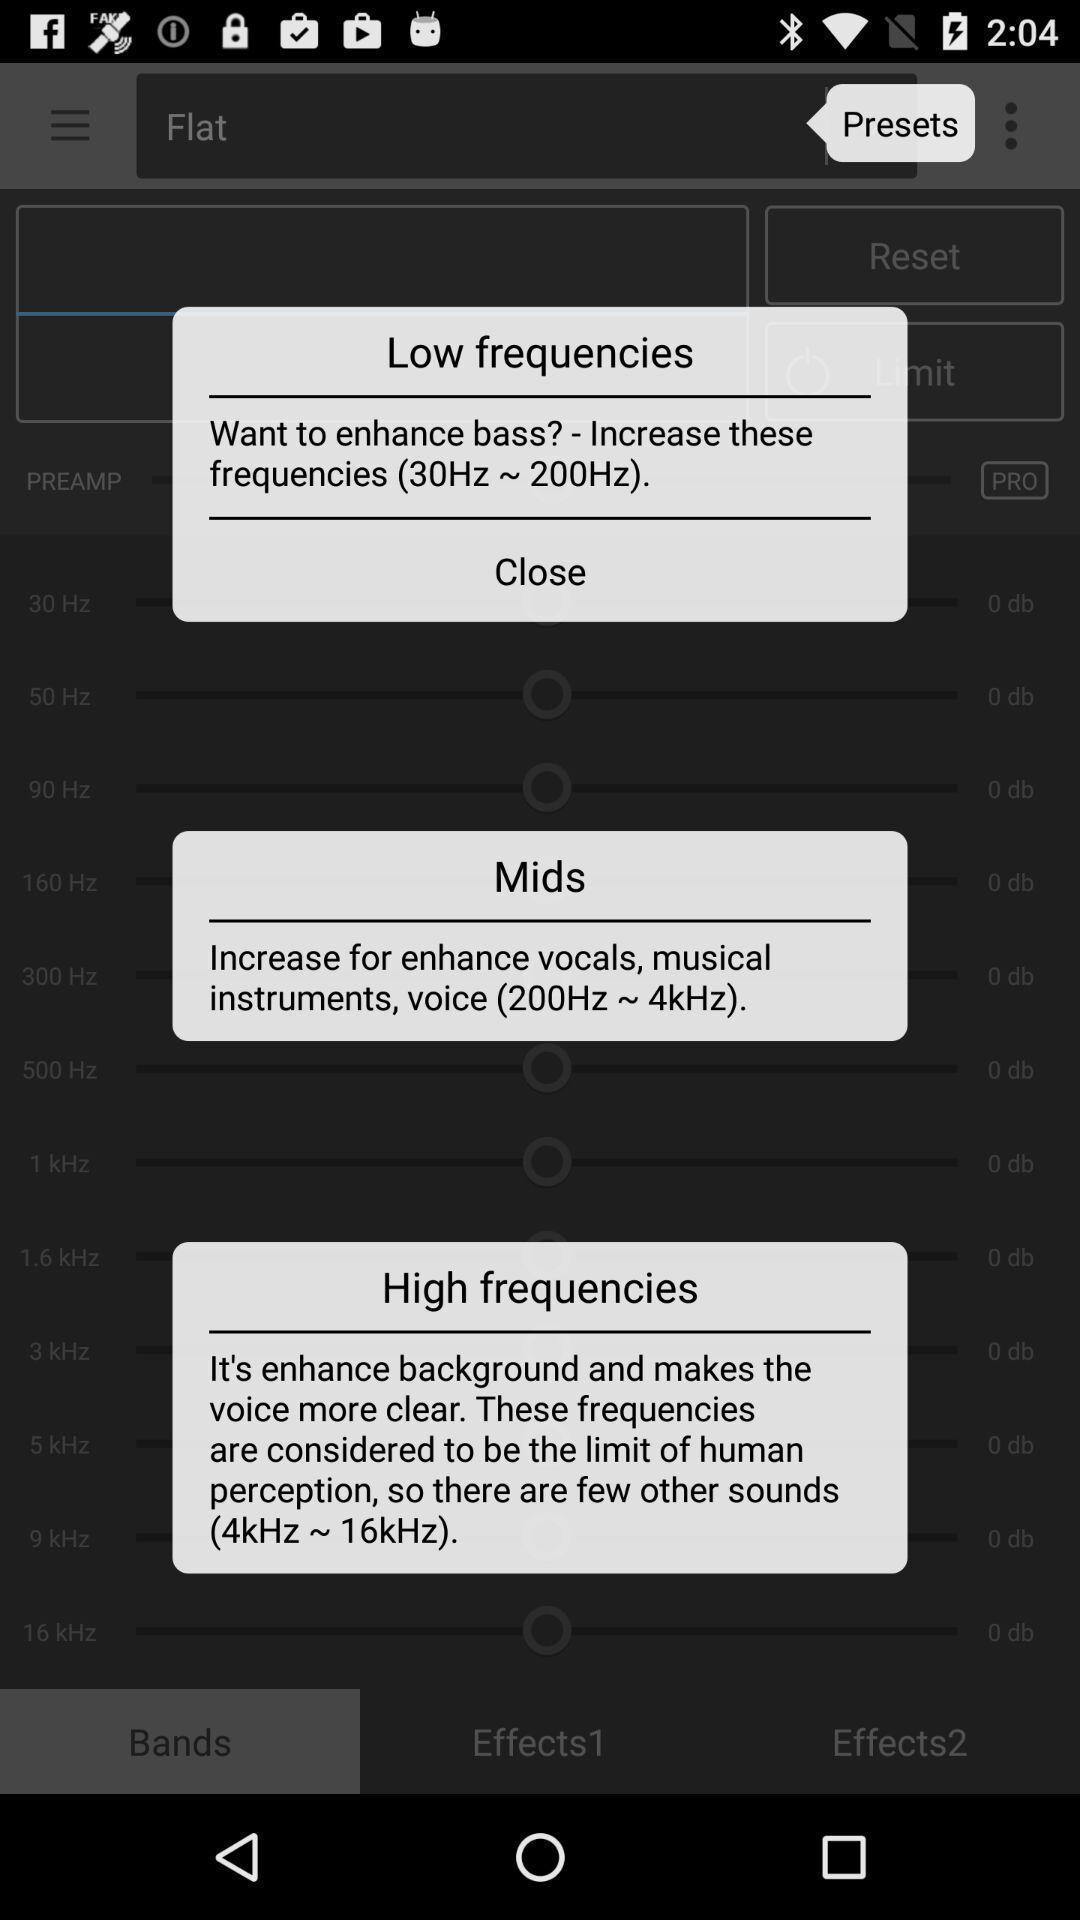Provide a detailed account of this screenshot. Screen showing frequencies. 